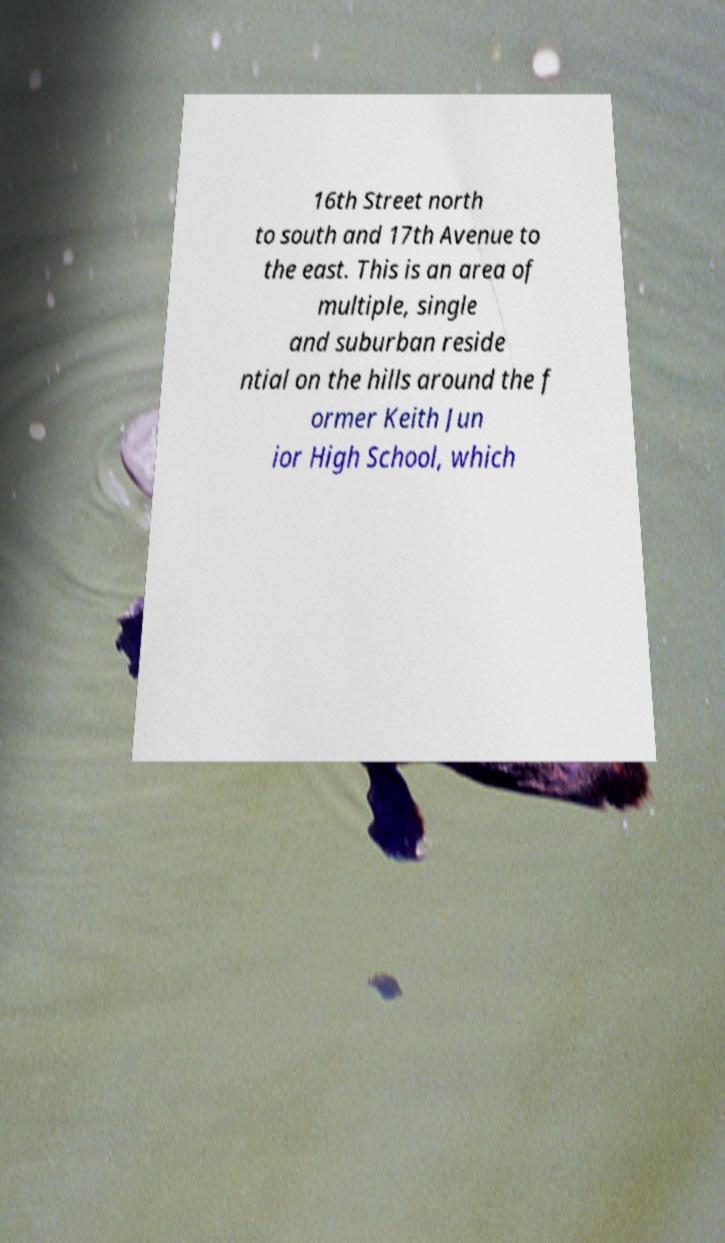Can you read and provide the text displayed in the image?This photo seems to have some interesting text. Can you extract and type it out for me? 16th Street north to south and 17th Avenue to the east. This is an area of multiple, single and suburban reside ntial on the hills around the f ormer Keith Jun ior High School, which 